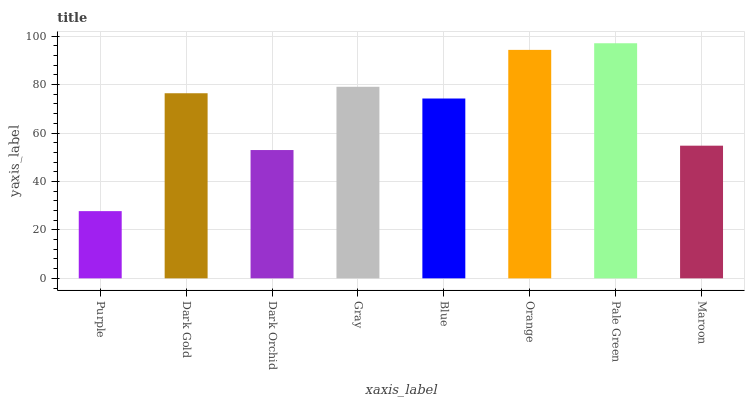Is Dark Gold the minimum?
Answer yes or no. No. Is Dark Gold the maximum?
Answer yes or no. No. Is Dark Gold greater than Purple?
Answer yes or no. Yes. Is Purple less than Dark Gold?
Answer yes or no. Yes. Is Purple greater than Dark Gold?
Answer yes or no. No. Is Dark Gold less than Purple?
Answer yes or no. No. Is Dark Gold the high median?
Answer yes or no. Yes. Is Blue the low median?
Answer yes or no. Yes. Is Pale Green the high median?
Answer yes or no. No. Is Dark Gold the low median?
Answer yes or no. No. 